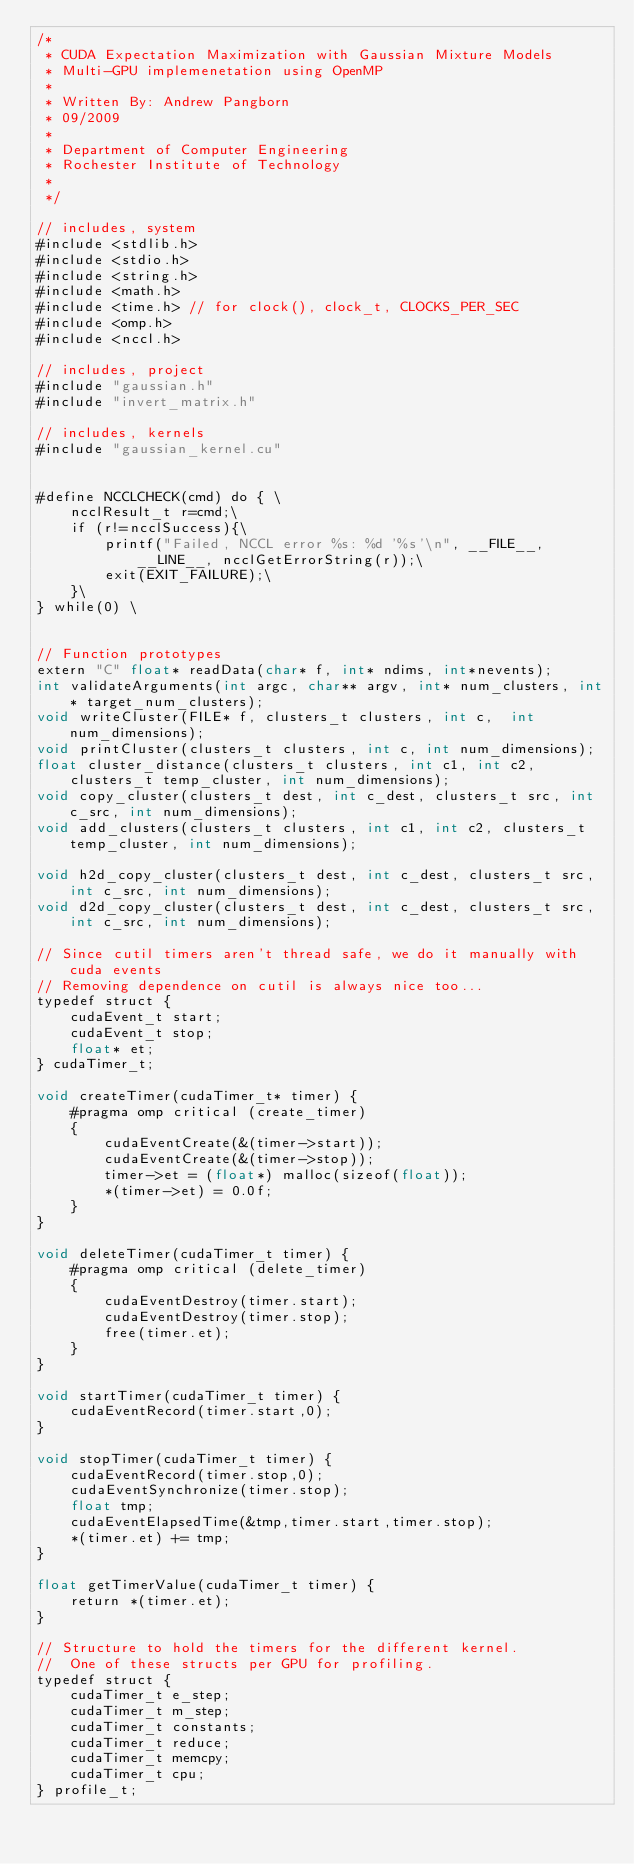Convert code to text. <code><loc_0><loc_0><loc_500><loc_500><_Cuda_>/*
 * CUDA Expectation Maximization with Gaussian Mixture Models
 * Multi-GPU implemenetation using OpenMP
 *
 * Written By: Andrew Pangborn
 * 09/2009
 *
 * Department of Computer Engineering
 * Rochester Institute of Technology
 *
 */

// includes, system
#include <stdlib.h>
#include <stdio.h>
#include <string.h>
#include <math.h>
#include <time.h> // for clock(), clock_t, CLOCKS_PER_SEC
#include <omp.h>
#include <nccl.h>

// includes, project
#include "gaussian.h"
#include "invert_matrix.h"

// includes, kernels
#include "gaussian_kernel.cu"


#define NCCLCHECK(cmd) do { \
    ncclResult_t r=cmd;\
    if (r!=ncclSuccess){\
        printf("Failed, NCCL error %s: %d '%s'\n", __FILE__, __LINE__, ncclGetErrorString(r));\
        exit(EXIT_FAILURE);\
    }\
} while(0) \


// Function prototypes
extern "C" float* readData(char* f, int* ndims, int*nevents);
int validateArguments(int argc, char** argv, int* num_clusters, int* target_num_clusters);
void writeCluster(FILE* f, clusters_t clusters, int c,  int num_dimensions);
void printCluster(clusters_t clusters, int c, int num_dimensions);
float cluster_distance(clusters_t clusters, int c1, int c2, clusters_t temp_cluster, int num_dimensions);
void copy_cluster(clusters_t dest, int c_dest, clusters_t src, int c_src, int num_dimensions);
void add_clusters(clusters_t clusters, int c1, int c2, clusters_t temp_cluster, int num_dimensions);

void h2d_copy_cluster(clusters_t dest, int c_dest, clusters_t src, int c_src, int num_dimensions);
void d2d_copy_cluster(clusters_t dest, int c_dest, clusters_t src, int c_src, int num_dimensions);

// Since cutil timers aren't thread safe, we do it manually with cuda events
// Removing dependence on cutil is always nice too...
typedef struct {
    cudaEvent_t start;
    cudaEvent_t stop;
    float* et;
} cudaTimer_t;

void createTimer(cudaTimer_t* timer) {
    #pragma omp critical (create_timer) 
    {
        cudaEventCreate(&(timer->start));
        cudaEventCreate(&(timer->stop));
        timer->et = (float*) malloc(sizeof(float));
        *(timer->et) = 0.0f;
    }
}

void deleteTimer(cudaTimer_t timer) {
    #pragma omp critical (delete_timer) 
    {
        cudaEventDestroy(timer.start);
        cudaEventDestroy(timer.stop);
        free(timer.et);
    }
}

void startTimer(cudaTimer_t timer) {
    cudaEventRecord(timer.start,0);
}

void stopTimer(cudaTimer_t timer) {
    cudaEventRecord(timer.stop,0);
    cudaEventSynchronize(timer.stop);
    float tmp;
    cudaEventElapsedTime(&tmp,timer.start,timer.stop);
    *(timer.et) += tmp;
}

float getTimerValue(cudaTimer_t timer) {
    return *(timer.et);
}

// Structure to hold the timers for the different kernel.
//  One of these structs per GPU for profiling.
typedef struct {
    cudaTimer_t e_step;
    cudaTimer_t m_step;
    cudaTimer_t constants;
    cudaTimer_t reduce;
    cudaTimer_t memcpy;
    cudaTimer_t cpu;
} profile_t;
</code> 